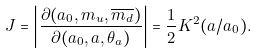Convert formula to latex. <formula><loc_0><loc_0><loc_500><loc_500>J = \left | \frac { \partial ( a _ { 0 } , m _ { u } , \overline { m _ { d } } ) } { \partial ( a _ { 0 } , a , \theta _ { a } ) } \right | = \frac { 1 } { 2 } K ^ { 2 } ( a / a _ { 0 } ) .</formula> 